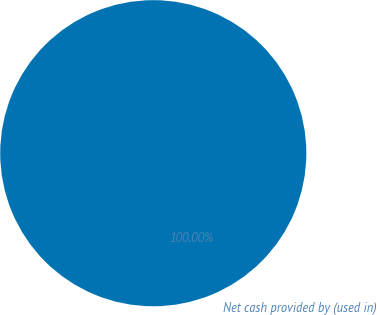<chart> <loc_0><loc_0><loc_500><loc_500><pie_chart><fcel>Net cash provided by (used in)<nl><fcel>100.0%<nl></chart> 